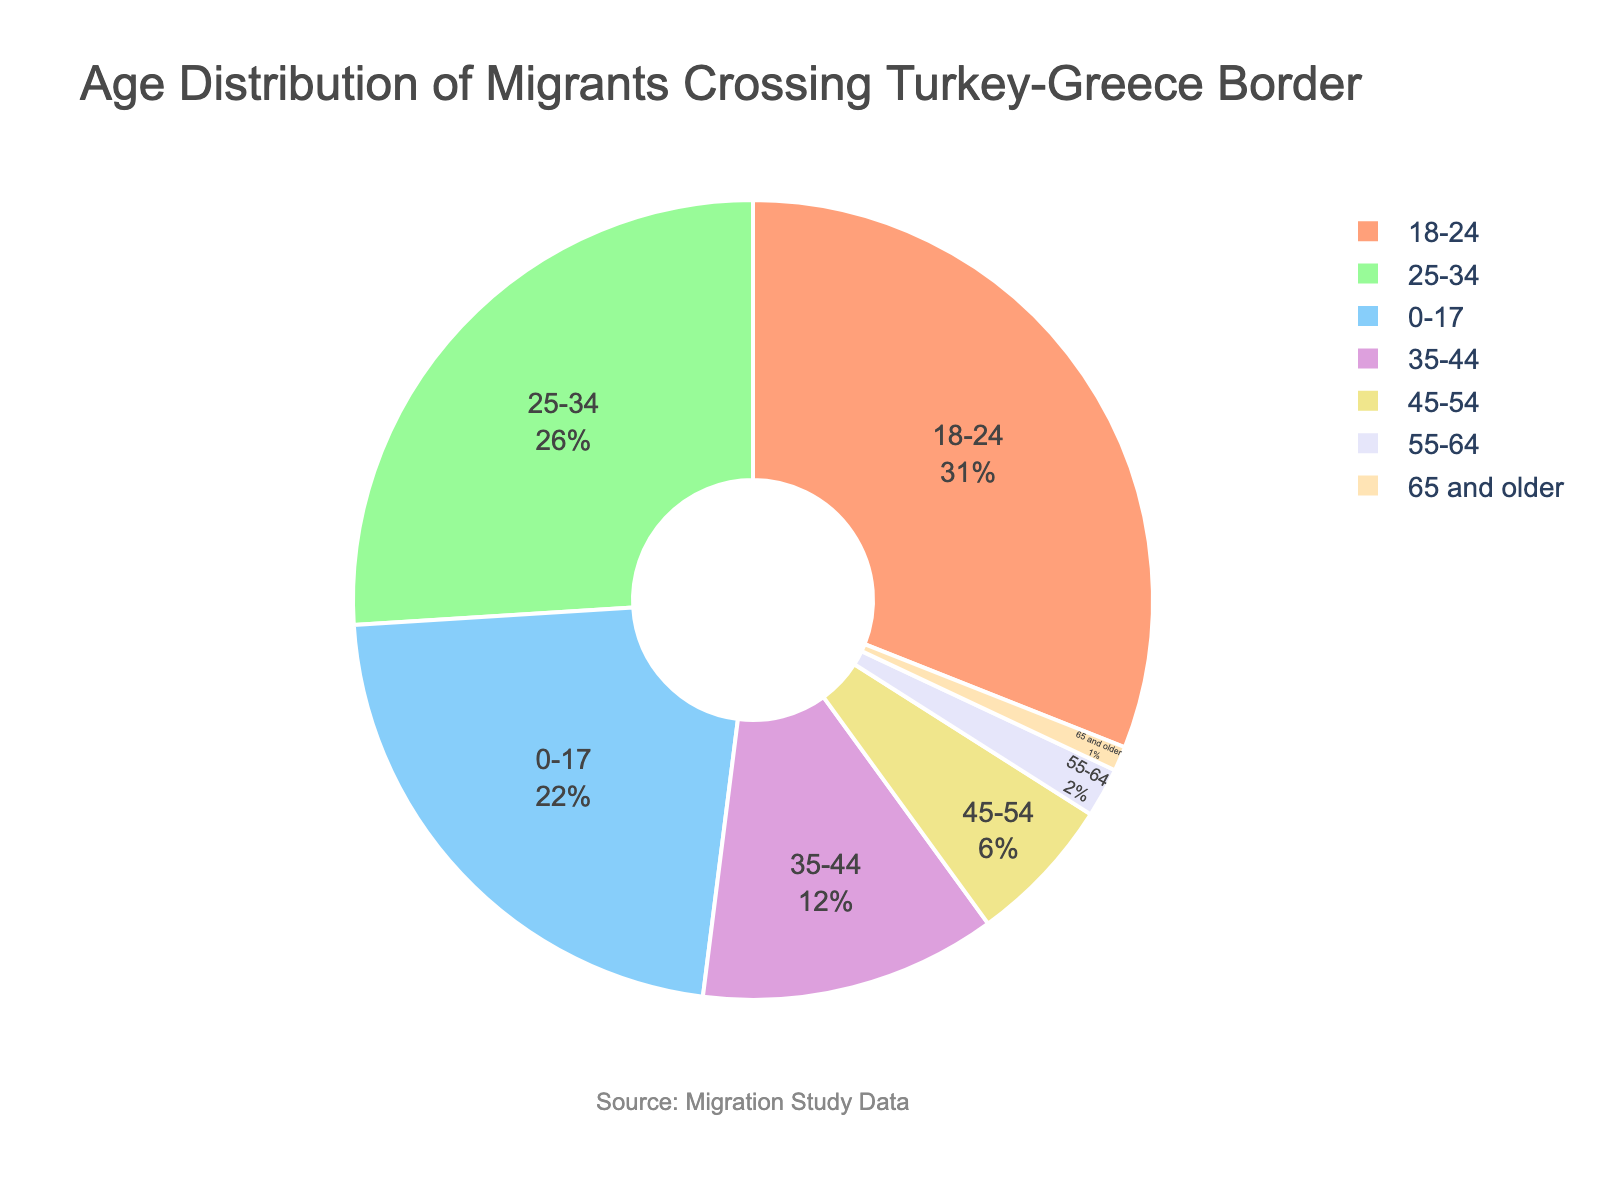What percentage of migrants are from the age group 18-24? The pie chart clearly labels the percentages for each age group. Looking at the age group 18-24, we can see it is labeled as 31%.
Answer: 31% Which age group contributes the least to the migrant population? The pie chart shows the percentages for each age group. The age group with the smallest slice is 65 and older, which is labeled as 1%.
Answer: 65 and older How much greater is the percentage of migrants aged 18-24 compared to those aged 35-44? From the pie chart, the percentage for the 18-24 group is 31% and for the 35-44 group is 12%. The difference is 31% - 12% = 19%.
Answer: 19% What is the combined percentage of migrants under 18 and those in the 25-34 age group? The pie chart shows that the percentage for the 0-17 age group is 22%, and for the 25-34 age group, it is 26%. Adding these together, the total is 22% + 26% = 48%.
Answer: 48% How does the percentage of migrants aged 45-54 compare to those aged 55-64? According to the pie chart, the percentage for the age group 45-54 is 6%, while for the 55-64 age group it is 2%. The difference is 6% - 2% = 4%, meaning the 45-54 age group has 4% more migrants.
Answer: 4% Identify the age group represented by the largest slice on the pie chart. By inspecting the pie chart, the largest slice belongs to the age group 18-24, which has a percentage of 31%.
Answer: 18-24 Which color corresponds to the age group 0-17 in the pie chart? The pie chart uses different colors for different age groups. The age group 0-17 is represented by the orange color slice.
Answer: Orange What proportion of the migrant population is 35 years or older? The pie chart shows the percentages for ages 35-44, 45-54, 55-64, and 65 and older as 12%, 6%, 2%, and 1%, respectively. Adding these gives a total of 12% + 6% + 2% + 1% = 21%.
Answer: 21% 